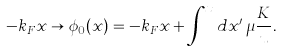<formula> <loc_0><loc_0><loc_500><loc_500>- k _ { F } x \rightarrow \phi _ { 0 } ( x ) = - k _ { F } x + \int ^ { x } d x ^ { \prime } \, \mu \frac { K } { u } .</formula> 